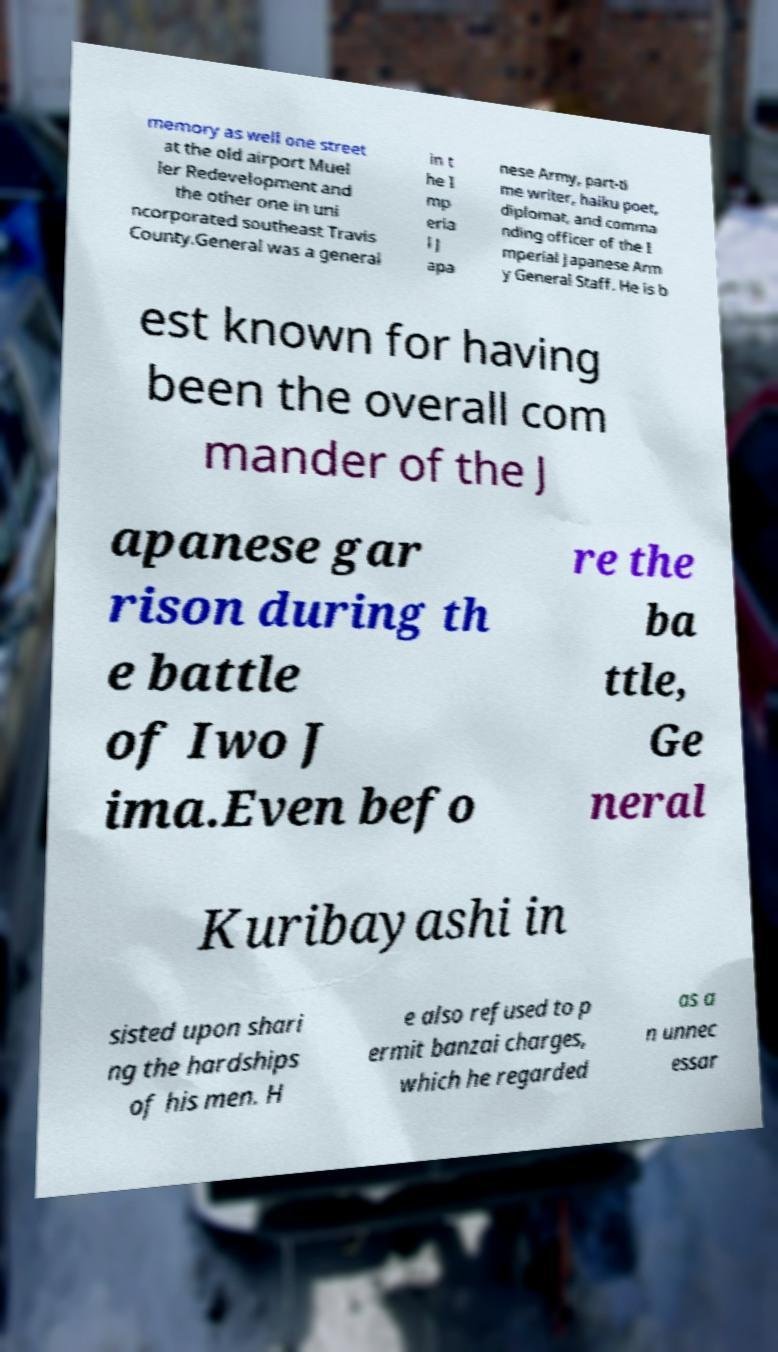What messages or text are displayed in this image? I need them in a readable, typed format. memory as well one street at the old airport Muel ler Redevelopment and the other one in uni ncorporated southeast Travis County.General was a general in t he I mp eria l J apa nese Army, part-ti me writer, haiku poet, diplomat, and comma nding officer of the I mperial Japanese Arm y General Staff. He is b est known for having been the overall com mander of the J apanese gar rison during th e battle of Iwo J ima.Even befo re the ba ttle, Ge neral Kuribayashi in sisted upon shari ng the hardships of his men. H e also refused to p ermit banzai charges, which he regarded as a n unnec essar 